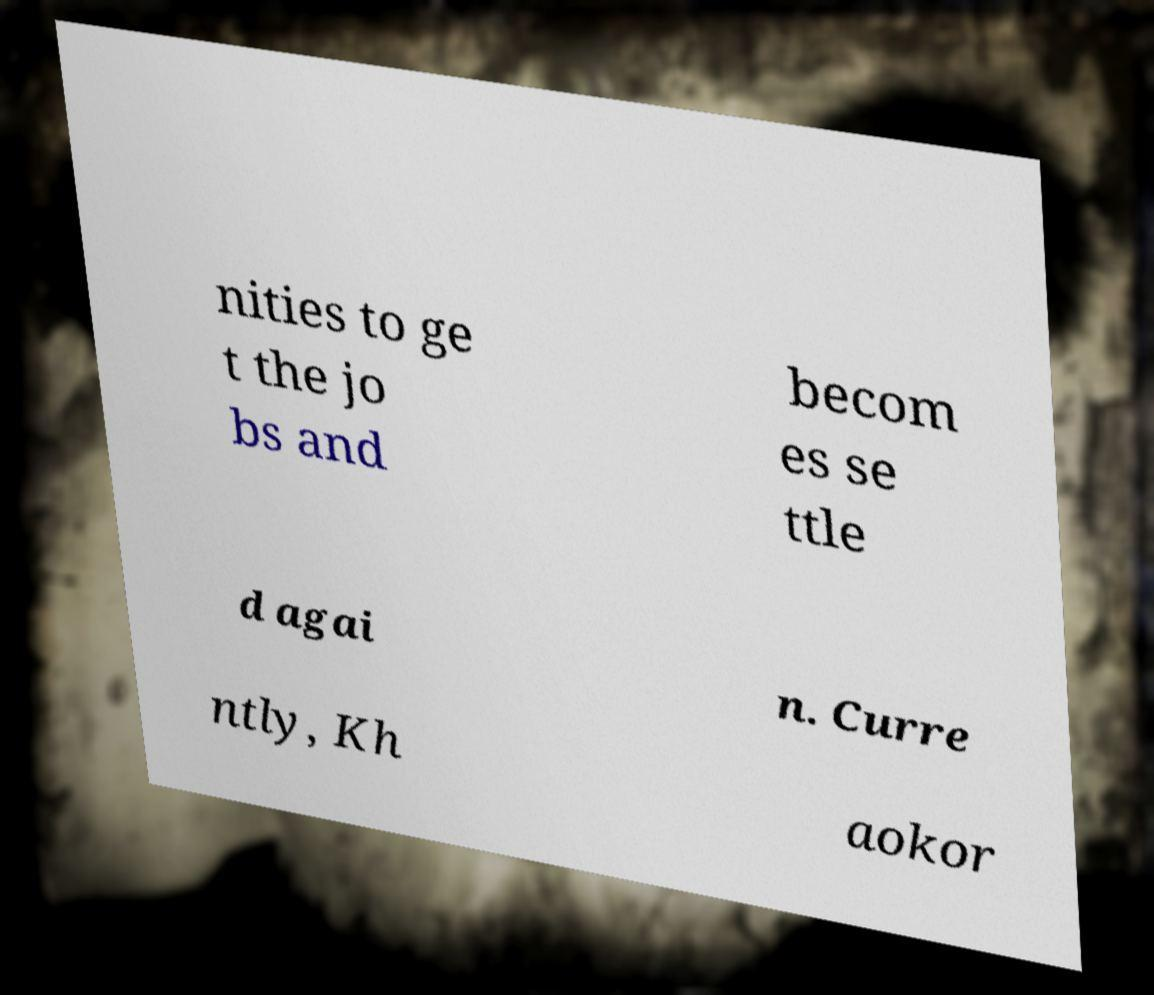There's text embedded in this image that I need extracted. Can you transcribe it verbatim? nities to ge t the jo bs and becom es se ttle d agai n. Curre ntly, Kh aokor 